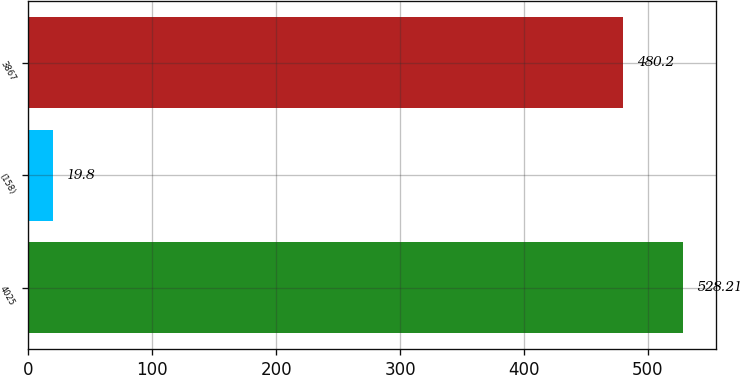Convert chart to OTSL. <chart><loc_0><loc_0><loc_500><loc_500><bar_chart><fcel>4025<fcel>(158)<fcel>3867<nl><fcel>528.21<fcel>19.8<fcel>480.2<nl></chart> 